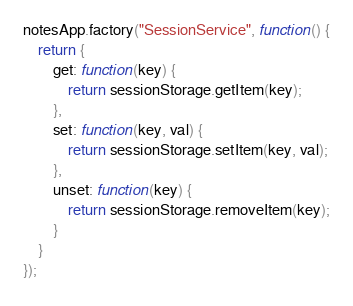<code> <loc_0><loc_0><loc_500><loc_500><_JavaScript_>notesApp.factory("SessionService", function() {
    return {
        get: function(key) {
            return sessionStorage.getItem(key);
        },
        set: function(key, val) {
            return sessionStorage.setItem(key, val);
        },
        unset: function(key) {
            return sessionStorage.removeItem(key);
        }
    }
});</code> 